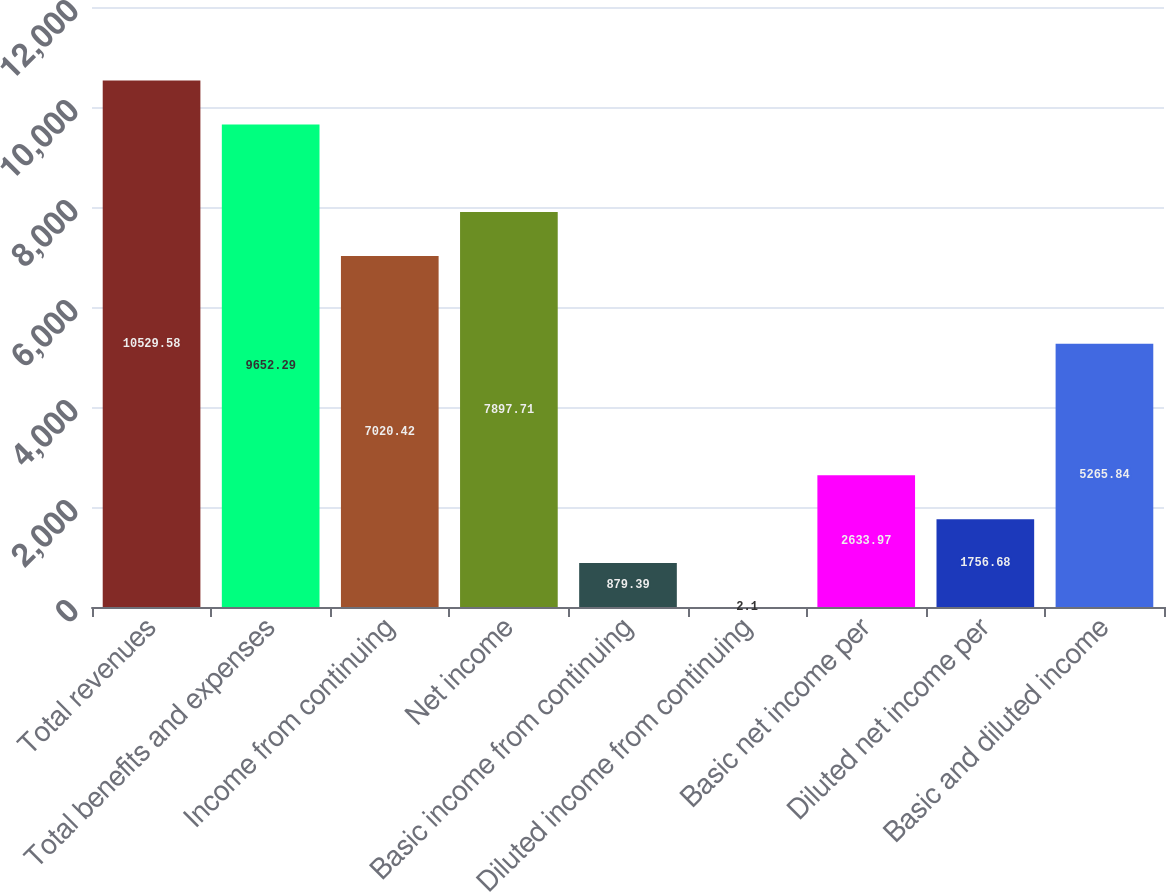Convert chart to OTSL. <chart><loc_0><loc_0><loc_500><loc_500><bar_chart><fcel>Total revenues<fcel>Total benefits and expenses<fcel>Income from continuing<fcel>Net income<fcel>Basic income from continuing<fcel>Diluted income from continuing<fcel>Basic net income per<fcel>Diluted net income per<fcel>Basic and diluted income<nl><fcel>10529.6<fcel>9652.29<fcel>7020.42<fcel>7897.71<fcel>879.39<fcel>2.1<fcel>2633.97<fcel>1756.68<fcel>5265.84<nl></chart> 